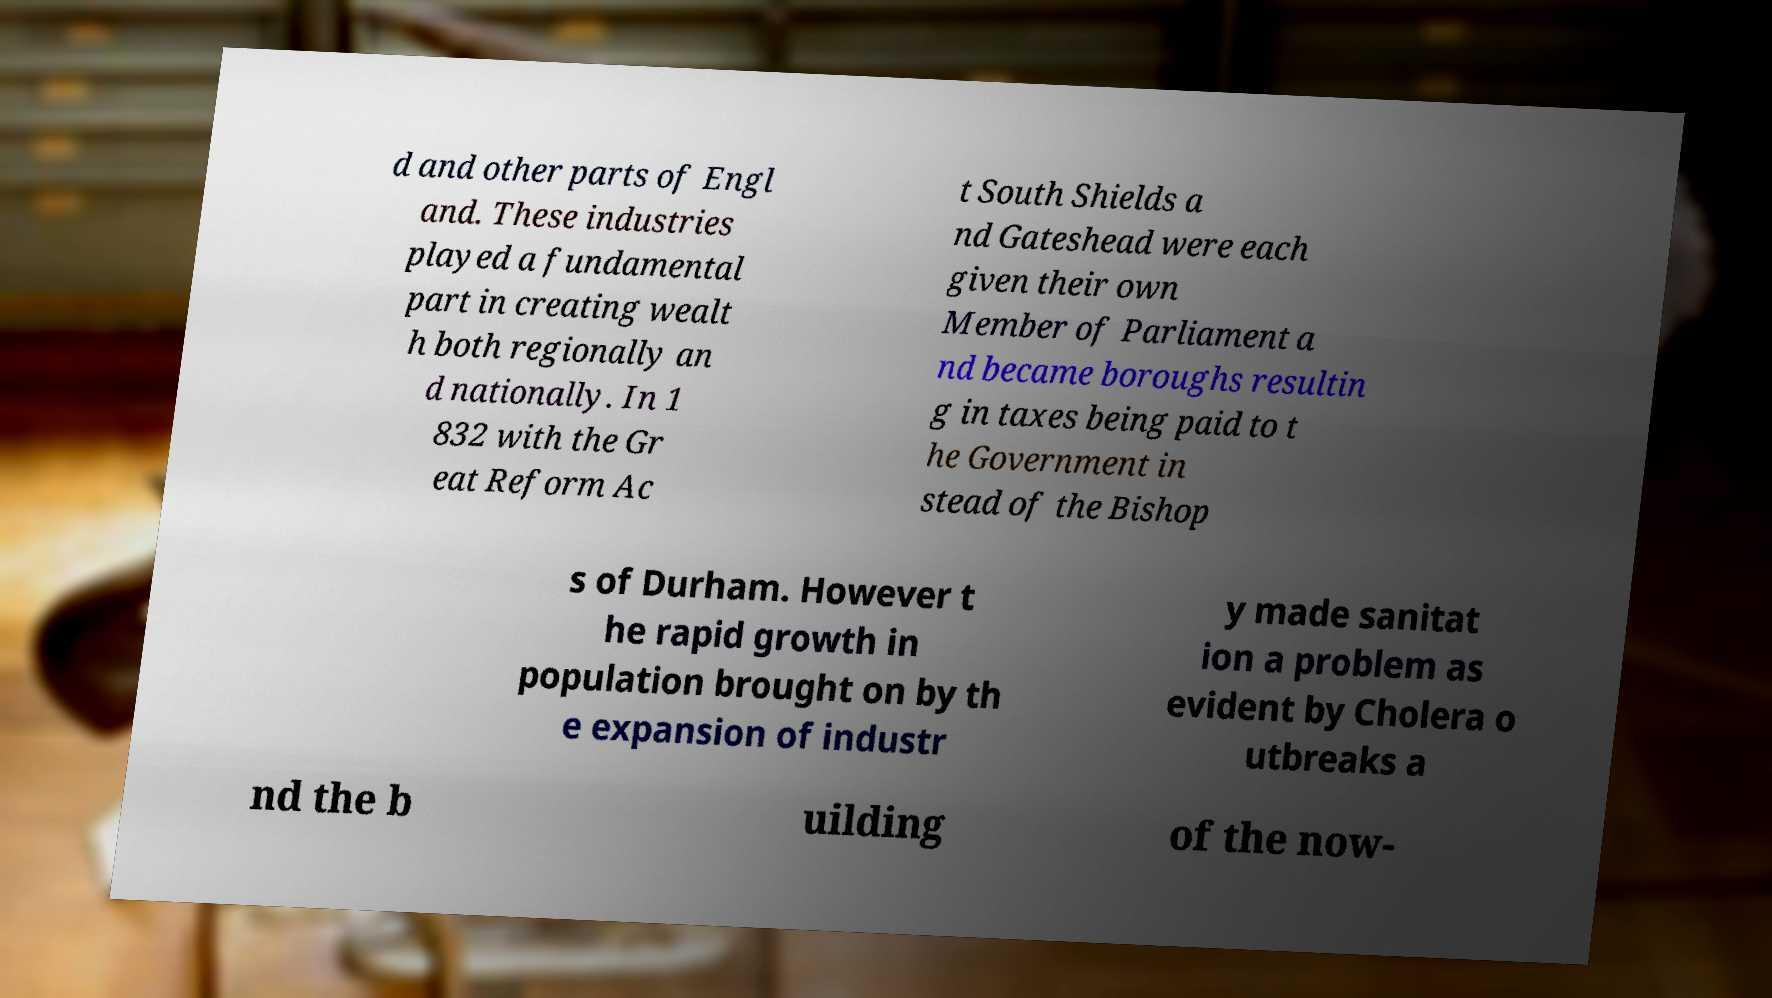There's text embedded in this image that I need extracted. Can you transcribe it verbatim? d and other parts of Engl and. These industries played a fundamental part in creating wealt h both regionally an d nationally. In 1 832 with the Gr eat Reform Ac t South Shields a nd Gateshead were each given their own Member of Parliament a nd became boroughs resultin g in taxes being paid to t he Government in stead of the Bishop s of Durham. However t he rapid growth in population brought on by th e expansion of industr y made sanitat ion a problem as evident by Cholera o utbreaks a nd the b uilding of the now- 